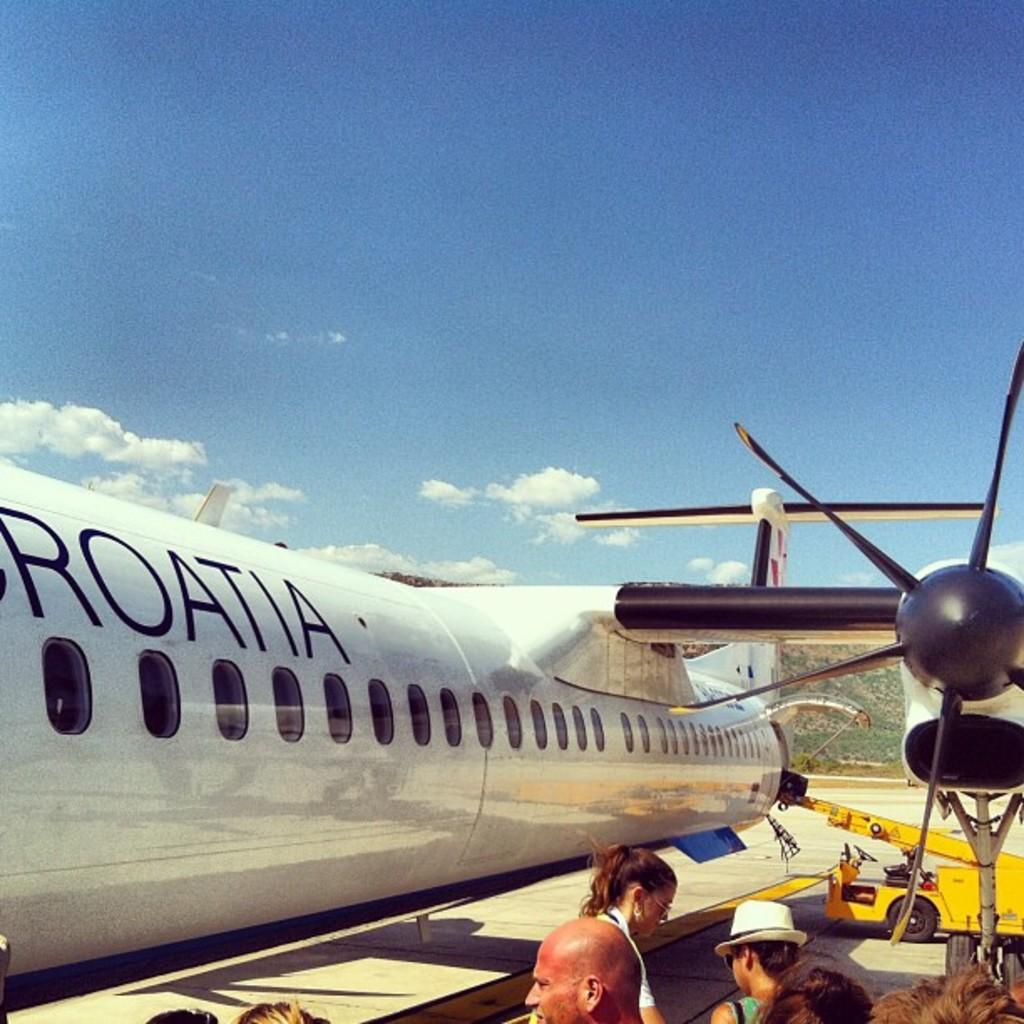<image>
Create a compact narrative representing the image presented. people waiting to board a white croatia plane 